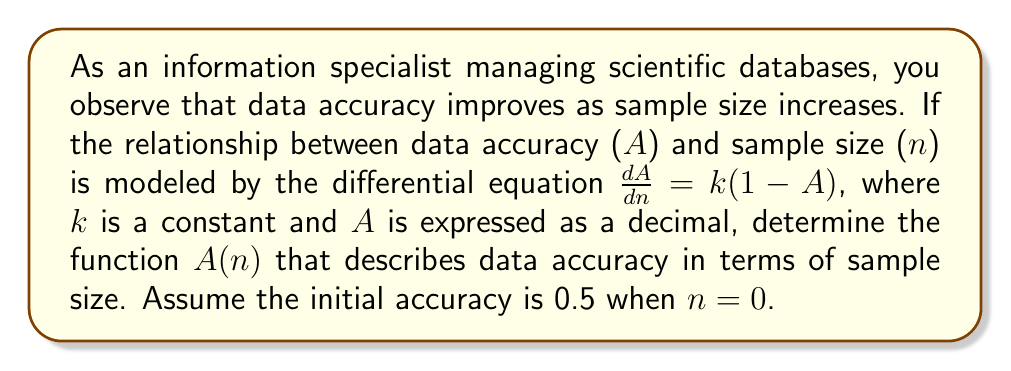Could you help me with this problem? To solve this problem, we'll follow these steps:

1) The given differential equation is:
   $$\frac{dA}{dn} = k(1-A)$$

2) This is a separable differential equation. We'll separate the variables:
   $$\frac{dA}{1-A} = k \, dn$$

3) Integrate both sides:
   $$\int \frac{dA}{1-A} = \int k \, dn$$

4) The left side integrates to $-\ln|1-A|$, and the right side to $kn + C$:
   $$-\ln|1-A| = kn + C$$

5) Solve for A:
   $$\ln|1-A| = -kn - C$$
   $$1-A = e^{-kn-C} = e^{-C} \cdot e^{-kn}$$
   $$A = 1 - Ce^{-kn}$$, where $C = e^{-C}$

6) Use the initial condition A = 0.5 when n = 0:
   $$0.5 = 1 - C$$
   $$C = 0.5$$

7) Therefore, the final solution is:
   $$A(n) = 1 - 0.5e^{-kn}$$
Answer: $A(n) = 1 - 0.5e^{-kn}$ 